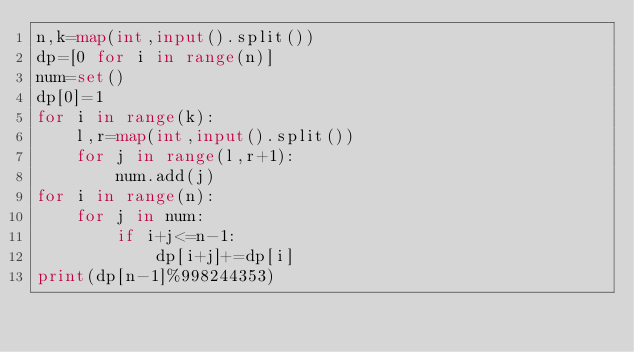<code> <loc_0><loc_0><loc_500><loc_500><_Python_>n,k=map(int,input().split())
dp=[0 for i in range(n)]
num=set()
dp[0]=1
for i in range(k):
    l,r=map(int,input().split())
    for j in range(l,r+1):
        num.add(j)
for i in range(n):
    for j in num:
        if i+j<=n-1:
            dp[i+j]+=dp[i]
print(dp[n-1]%998244353)</code> 